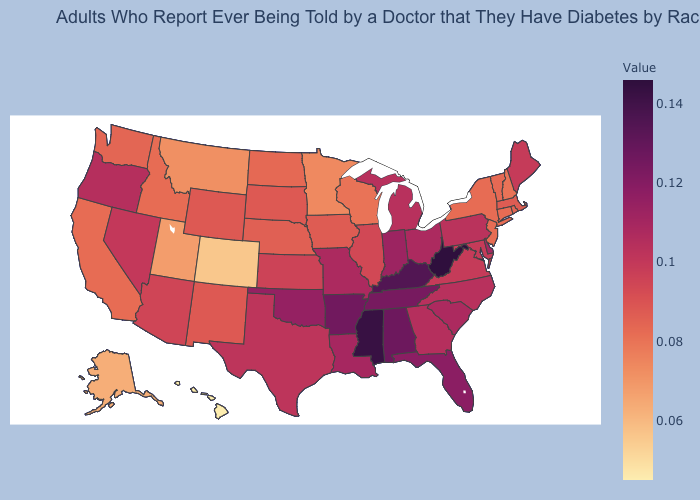Does New Hampshire have the lowest value in the Northeast?
Answer briefly. Yes. Among the states that border South Dakota , which have the highest value?
Write a very short answer. Wyoming. Which states hav the highest value in the West?
Short answer required. Oregon. Among the states that border Idaho , does Nevada have the lowest value?
Quick response, please. No. Among the states that border Oregon , which have the highest value?
Be succinct. Nevada. Does Minnesota have a lower value than Michigan?
Be succinct. Yes. Does Colorado have the lowest value in the USA?
Be succinct. No. 